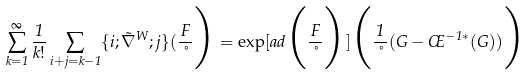Convert formula to latex. <formula><loc_0><loc_0><loc_500><loc_500>\sum _ { k = 1 } ^ { \infty } \frac { 1 } { k ! } \sum _ { i + j = k - 1 } \{ i ; \tilde { \nabla } ^ { W } ; j \} ( \frac { F } { \nu } \Big ) = \exp [ a d \Big ( \frac { F } { \nu } \Big ) ] \Big ( \frac { 1 } { \nu } ( G - \phi ^ { - 1 * } ( G ) ) \Big )</formula> 